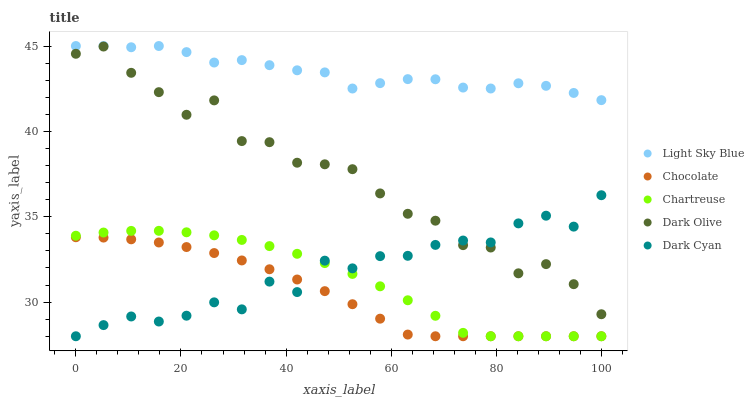Does Chocolate have the minimum area under the curve?
Answer yes or no. Yes. Does Light Sky Blue have the maximum area under the curve?
Answer yes or no. Yes. Does Dark Cyan have the minimum area under the curve?
Answer yes or no. No. Does Dark Cyan have the maximum area under the curve?
Answer yes or no. No. Is Chocolate the smoothest?
Answer yes or no. Yes. Is Dark Olive the roughest?
Answer yes or no. Yes. Is Dark Cyan the smoothest?
Answer yes or no. No. Is Dark Cyan the roughest?
Answer yes or no. No. Does Dark Cyan have the lowest value?
Answer yes or no. Yes. Does Light Sky Blue have the lowest value?
Answer yes or no. No. Does Light Sky Blue have the highest value?
Answer yes or no. Yes. Does Dark Cyan have the highest value?
Answer yes or no. No. Is Chartreuse less than Light Sky Blue?
Answer yes or no. Yes. Is Light Sky Blue greater than Dark Cyan?
Answer yes or no. Yes. Does Chartreuse intersect Dark Cyan?
Answer yes or no. Yes. Is Chartreuse less than Dark Cyan?
Answer yes or no. No. Is Chartreuse greater than Dark Cyan?
Answer yes or no. No. Does Chartreuse intersect Light Sky Blue?
Answer yes or no. No. 